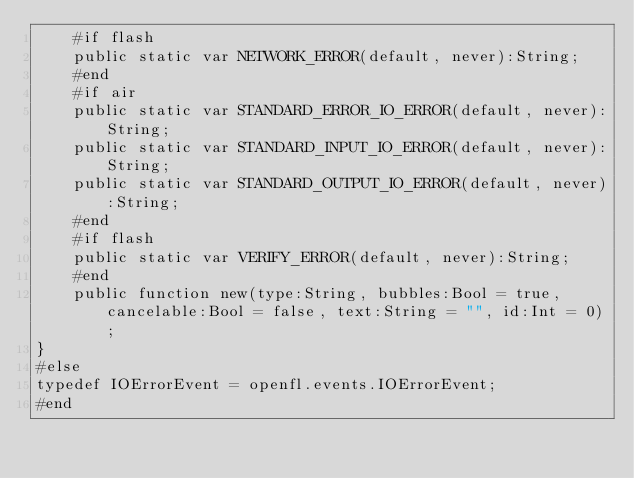Convert code to text. <code><loc_0><loc_0><loc_500><loc_500><_Haxe_>	#if flash
	public static var NETWORK_ERROR(default, never):String;
	#end
	#if air
	public static var STANDARD_ERROR_IO_ERROR(default, never):String;
	public static var STANDARD_INPUT_IO_ERROR(default, never):String;
	public static var STANDARD_OUTPUT_IO_ERROR(default, never):String;
	#end
	#if flash
	public static var VERIFY_ERROR(default, never):String;
	#end
	public function new(type:String, bubbles:Bool = true, cancelable:Bool = false, text:String = "", id:Int = 0);
}
#else
typedef IOErrorEvent = openfl.events.IOErrorEvent;
#end
</code> 